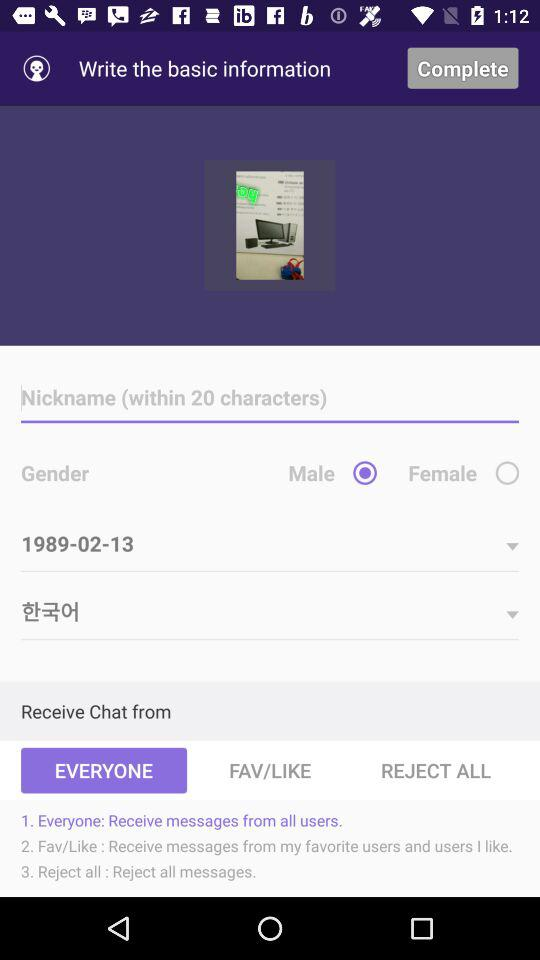Within how many characters is a nickname chosen? A nickname is chosen within 20 characters. 